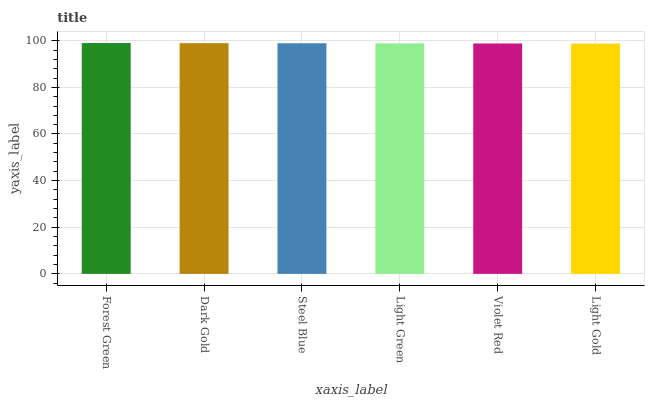Is Light Gold the minimum?
Answer yes or no. Yes. Is Forest Green the maximum?
Answer yes or no. Yes. Is Dark Gold the minimum?
Answer yes or no. No. Is Dark Gold the maximum?
Answer yes or no. No. Is Forest Green greater than Dark Gold?
Answer yes or no. Yes. Is Dark Gold less than Forest Green?
Answer yes or no. Yes. Is Dark Gold greater than Forest Green?
Answer yes or no. No. Is Forest Green less than Dark Gold?
Answer yes or no. No. Is Steel Blue the high median?
Answer yes or no. Yes. Is Light Green the low median?
Answer yes or no. Yes. Is Forest Green the high median?
Answer yes or no. No. Is Forest Green the low median?
Answer yes or no. No. 